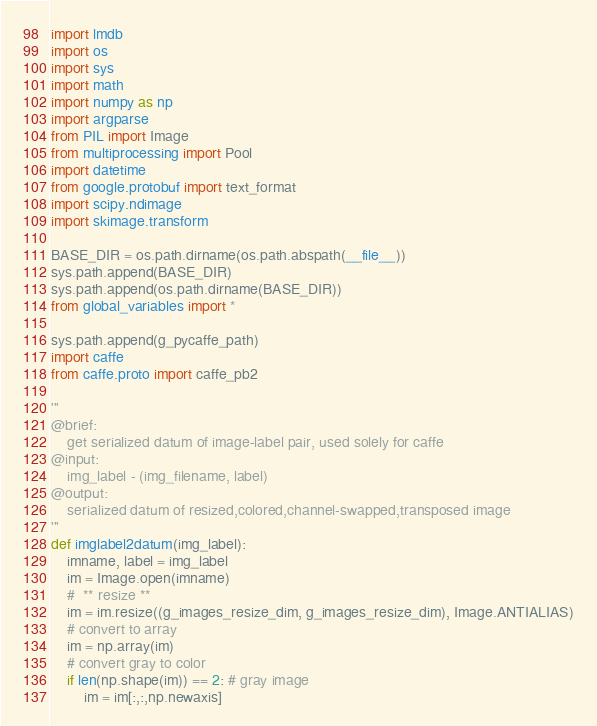Convert code to text. <code><loc_0><loc_0><loc_500><loc_500><_Python_>
import lmdb
import os
import sys
import math
import numpy as np
import argparse
from PIL import Image
from multiprocessing import Pool
import datetime
from google.protobuf import text_format
import scipy.ndimage
import skimage.transform

BASE_DIR = os.path.dirname(os.path.abspath(__file__))
sys.path.append(BASE_DIR)
sys.path.append(os.path.dirname(BASE_DIR))
from global_variables import *

sys.path.append(g_pycaffe_path)
import caffe
from caffe.proto import caffe_pb2

'''
@brief:
    get serialized datum of image-label pair, used solely for caffe
@input:
    img_label - (img_filename, label)
@output:
    serialized datum of resized,colored,channel-swapped,transposed image
'''
def imglabel2datum(img_label):
    imname, label = img_label
    im = Image.open(imname)
    #  ** resize **
    im = im.resize((g_images_resize_dim, g_images_resize_dim), Image.ANTIALIAS)
    # convert to array
    im = np.array(im)
    # convert gray to color
    if len(np.shape(im)) == 2: # gray image
        im = im[:,:,np.newaxis]</code> 